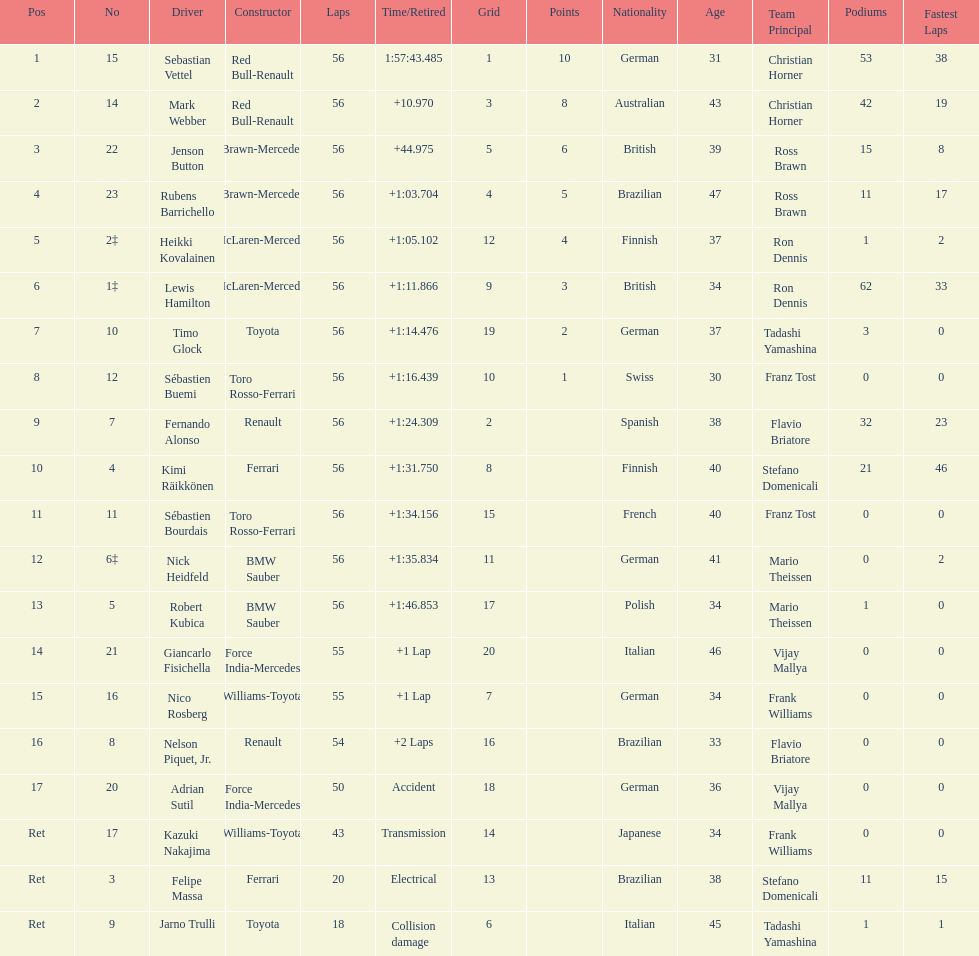What is the overall count of drivers mentioned in the list? 20. 